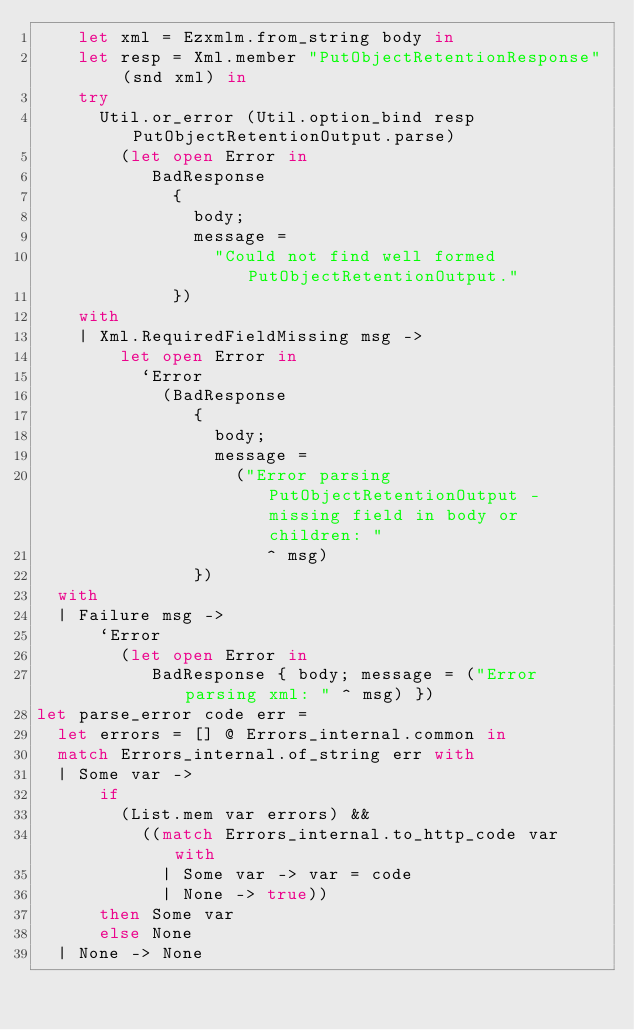<code> <loc_0><loc_0><loc_500><loc_500><_OCaml_>    let xml = Ezxmlm.from_string body in
    let resp = Xml.member "PutObjectRetentionResponse" (snd xml) in
    try
      Util.or_error (Util.option_bind resp PutObjectRetentionOutput.parse)
        (let open Error in
           BadResponse
             {
               body;
               message =
                 "Could not find well formed PutObjectRetentionOutput."
             })
    with
    | Xml.RequiredFieldMissing msg ->
        let open Error in
          `Error
            (BadResponse
               {
                 body;
                 message =
                   ("Error parsing PutObjectRetentionOutput - missing field in body or children: "
                      ^ msg)
               })
  with
  | Failure msg ->
      `Error
        (let open Error in
           BadResponse { body; message = ("Error parsing xml: " ^ msg) })
let parse_error code err =
  let errors = [] @ Errors_internal.common in
  match Errors_internal.of_string err with
  | Some var ->
      if
        (List.mem var errors) &&
          ((match Errors_internal.to_http_code var with
            | Some var -> var = code
            | None -> true))
      then Some var
      else None
  | None -> None</code> 